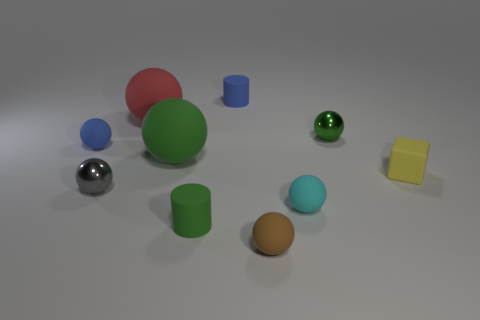Subtract all shiny balls. How many balls are left? 5 Subtract all brown balls. How many balls are left? 6 Add 3 tiny shiny spheres. How many tiny shiny spheres are left? 5 Add 5 blue cylinders. How many blue cylinders exist? 6 Subtract 0 blue blocks. How many objects are left? 10 Subtract all cylinders. How many objects are left? 8 Subtract 1 blocks. How many blocks are left? 0 Subtract all red balls. Subtract all gray cubes. How many balls are left? 6 Subtract all blue cylinders. How many yellow balls are left? 0 Subtract all rubber balls. Subtract all rubber cubes. How many objects are left? 4 